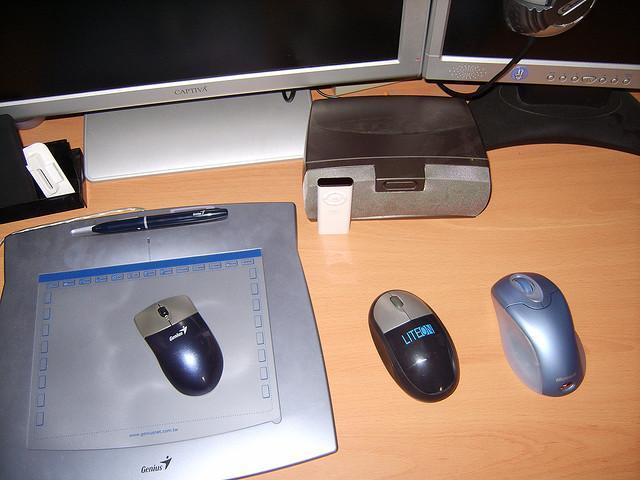How many mice can you see?
Give a very brief answer. 3. How many tvs are in the picture?
Give a very brief answer. 2. How many people have on sweaters?
Give a very brief answer. 0. 